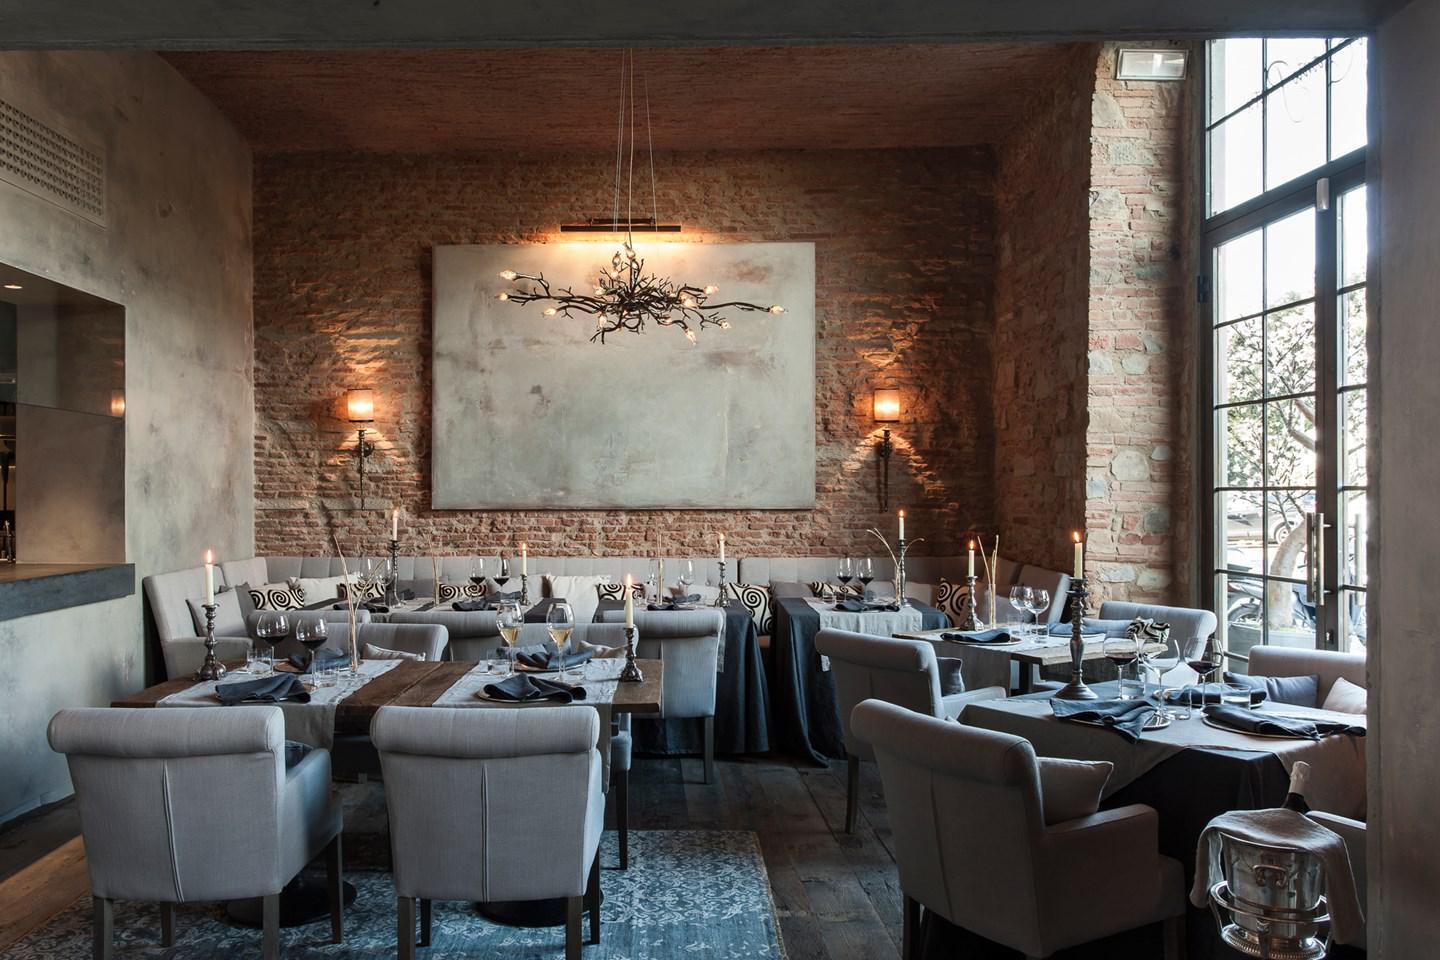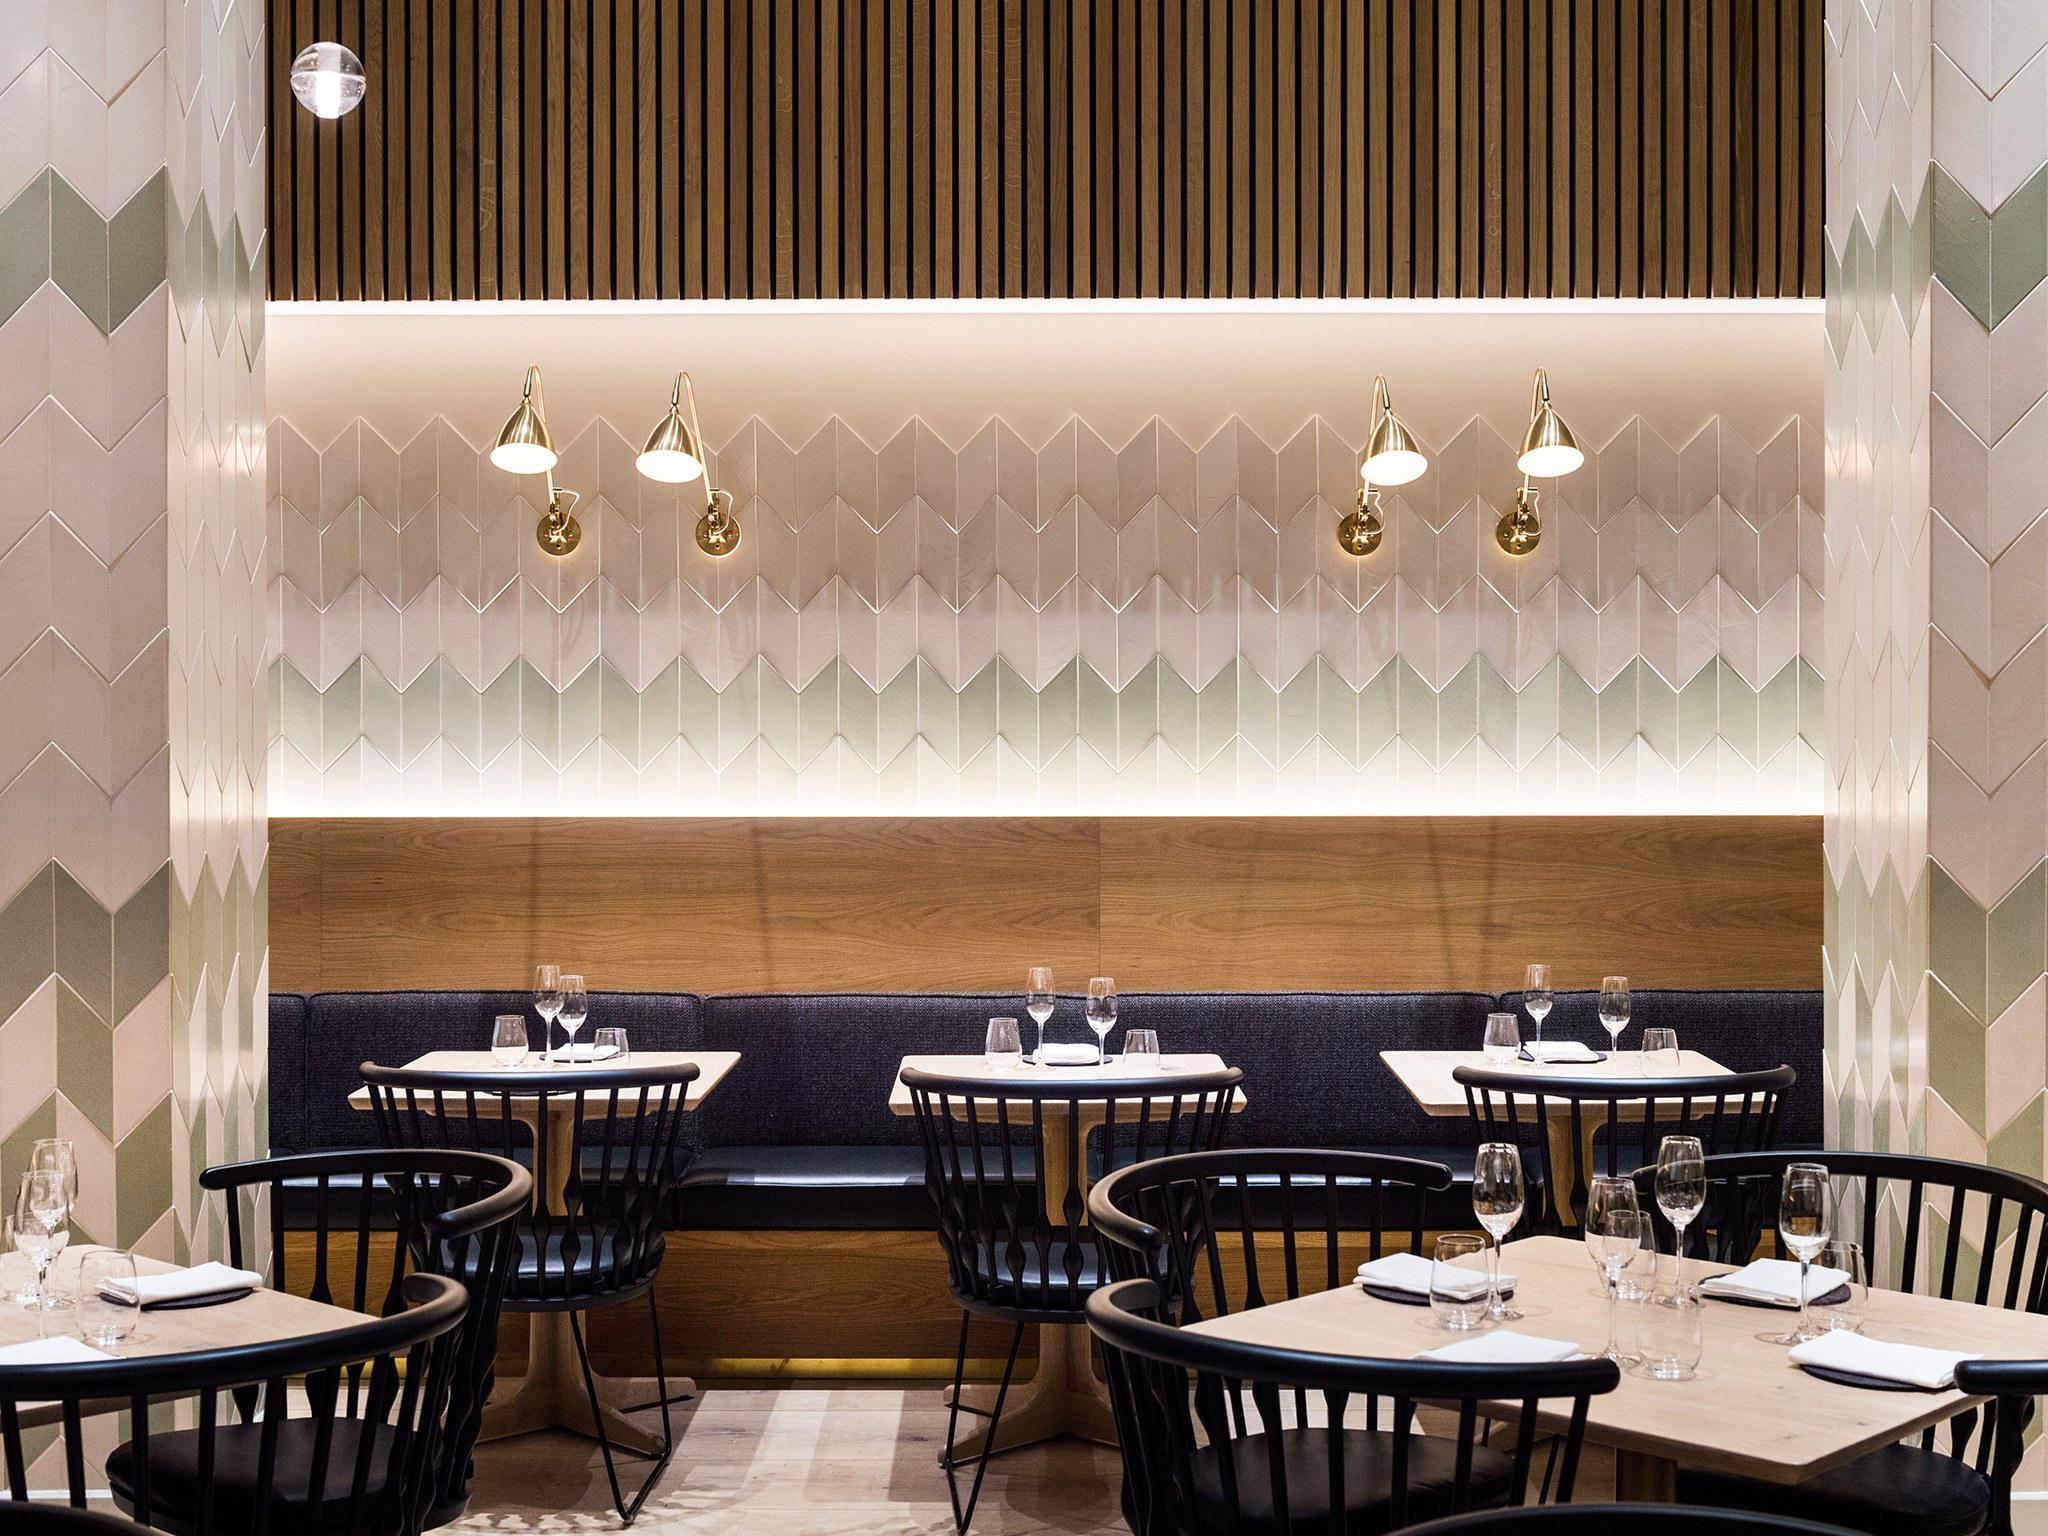The first image is the image on the left, the second image is the image on the right. For the images displayed, is the sentence "There are some lighting fixtures on the rear walls, instead of just on the ceilings." factually correct? Answer yes or no. Yes. 